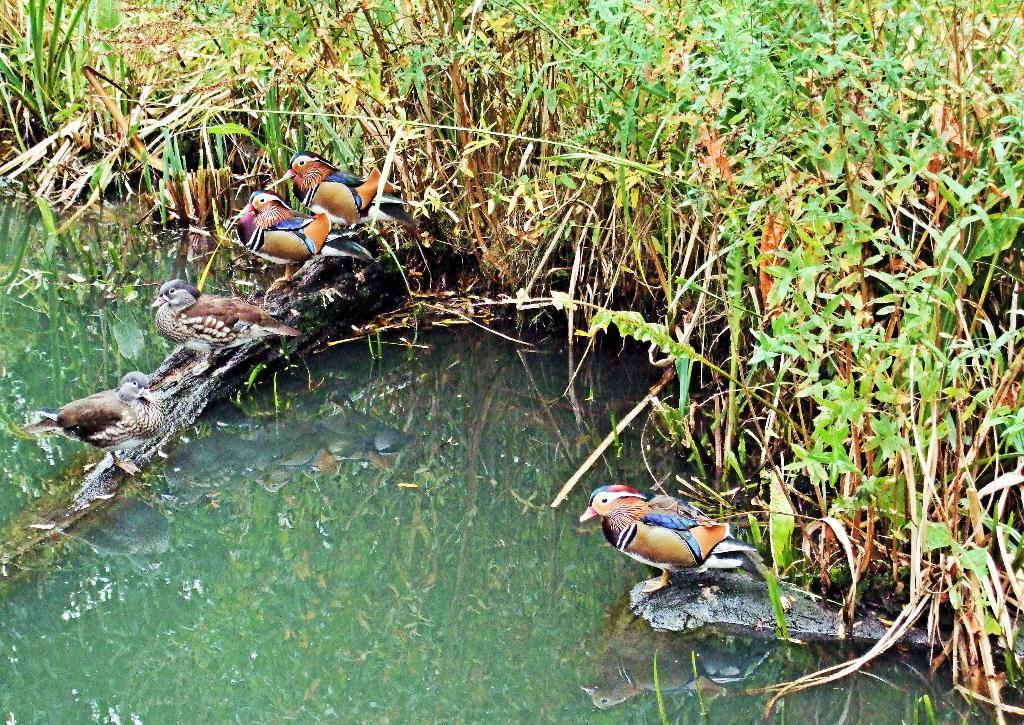What type of animals can be seen in the image? Birds can be seen in the image. What other elements are present in the image besides the birds? There are plants in the image. What is the reflection of in the water? The reflection of the birds and plants is visible on the water. How many bags can be seen floating in the water in the image? There are no bags present in the image; it features birds, plants, and their reflections on the water. 